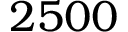<formula> <loc_0><loc_0><loc_500><loc_500>2 5 0 0</formula> 